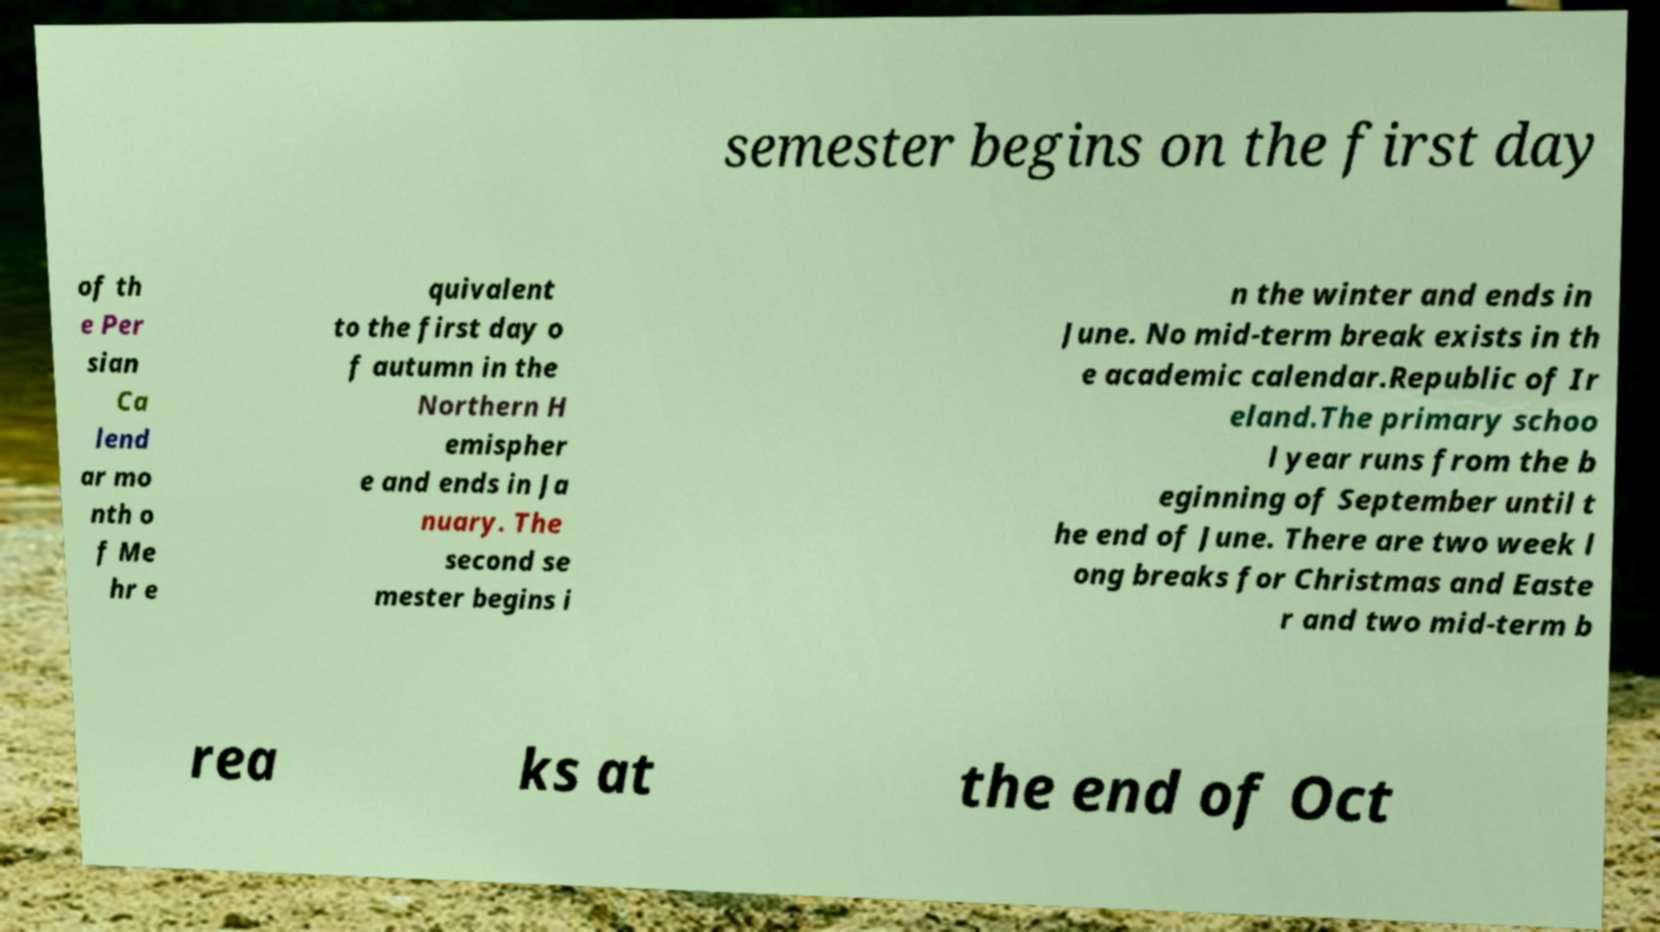There's text embedded in this image that I need extracted. Can you transcribe it verbatim? semester begins on the first day of th e Per sian Ca lend ar mo nth o f Me hr e quivalent to the first day o f autumn in the Northern H emispher e and ends in Ja nuary. The second se mester begins i n the winter and ends in June. No mid-term break exists in th e academic calendar.Republic of Ir eland.The primary schoo l year runs from the b eginning of September until t he end of June. There are two week l ong breaks for Christmas and Easte r and two mid-term b rea ks at the end of Oct 